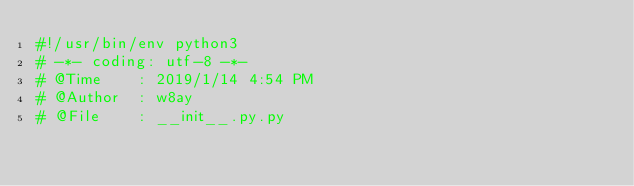Convert code to text. <code><loc_0><loc_0><loc_500><loc_500><_Python_>#!/usr/bin/env python3
# -*- coding: utf-8 -*-
# @Time    : 2019/1/14 4:54 PM
# @Author  : w8ay
# @File    : __init__.py.py
</code> 